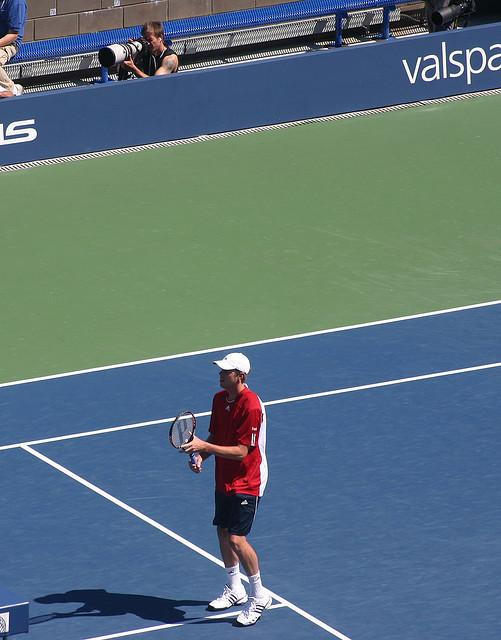How many visible stripes are in his right shoe? three 